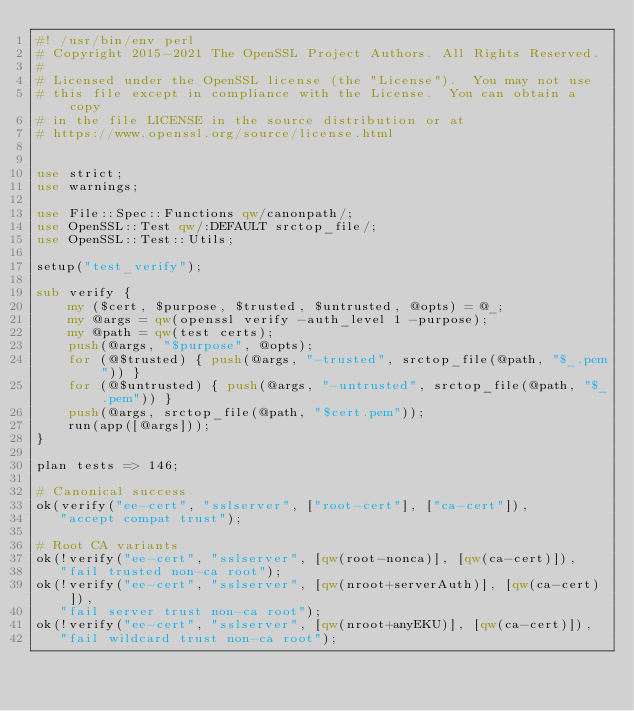Convert code to text. <code><loc_0><loc_0><loc_500><loc_500><_Perl_>#! /usr/bin/env perl
# Copyright 2015-2021 The OpenSSL Project Authors. All Rights Reserved.
#
# Licensed under the OpenSSL license (the "License").  You may not use
# this file except in compliance with the License.  You can obtain a copy
# in the file LICENSE in the source distribution or at
# https://www.openssl.org/source/license.html


use strict;
use warnings;

use File::Spec::Functions qw/canonpath/;
use OpenSSL::Test qw/:DEFAULT srctop_file/;
use OpenSSL::Test::Utils;

setup("test_verify");

sub verify {
    my ($cert, $purpose, $trusted, $untrusted, @opts) = @_;
    my @args = qw(openssl verify -auth_level 1 -purpose);
    my @path = qw(test certs);
    push(@args, "$purpose", @opts);
    for (@$trusted) { push(@args, "-trusted", srctop_file(@path, "$_.pem")) }
    for (@$untrusted) { push(@args, "-untrusted", srctop_file(@path, "$_.pem")) }
    push(@args, srctop_file(@path, "$cert.pem"));
    run(app([@args]));
}

plan tests => 146;

# Canonical success
ok(verify("ee-cert", "sslserver", ["root-cert"], ["ca-cert"]),
   "accept compat trust");

# Root CA variants
ok(!verify("ee-cert", "sslserver", [qw(root-nonca)], [qw(ca-cert)]),
   "fail trusted non-ca root");
ok(!verify("ee-cert", "sslserver", [qw(nroot+serverAuth)], [qw(ca-cert)]),
   "fail server trust non-ca root");
ok(!verify("ee-cert", "sslserver", [qw(nroot+anyEKU)], [qw(ca-cert)]),
   "fail wildcard trust non-ca root");</code> 